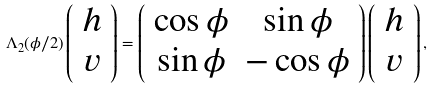<formula> <loc_0><loc_0><loc_500><loc_500>\Lambda _ { 2 } ( \phi / 2 ) \left ( \begin{array} { c } h \\ v \\ \end{array} \right ) = \left ( \begin{array} { c c } \cos \phi & \sin \phi \\ \sin \phi & - \cos \phi \\ \end{array} \right ) \left ( \begin{array} { c } h \\ v \\ \end{array} \right ) ,</formula> 